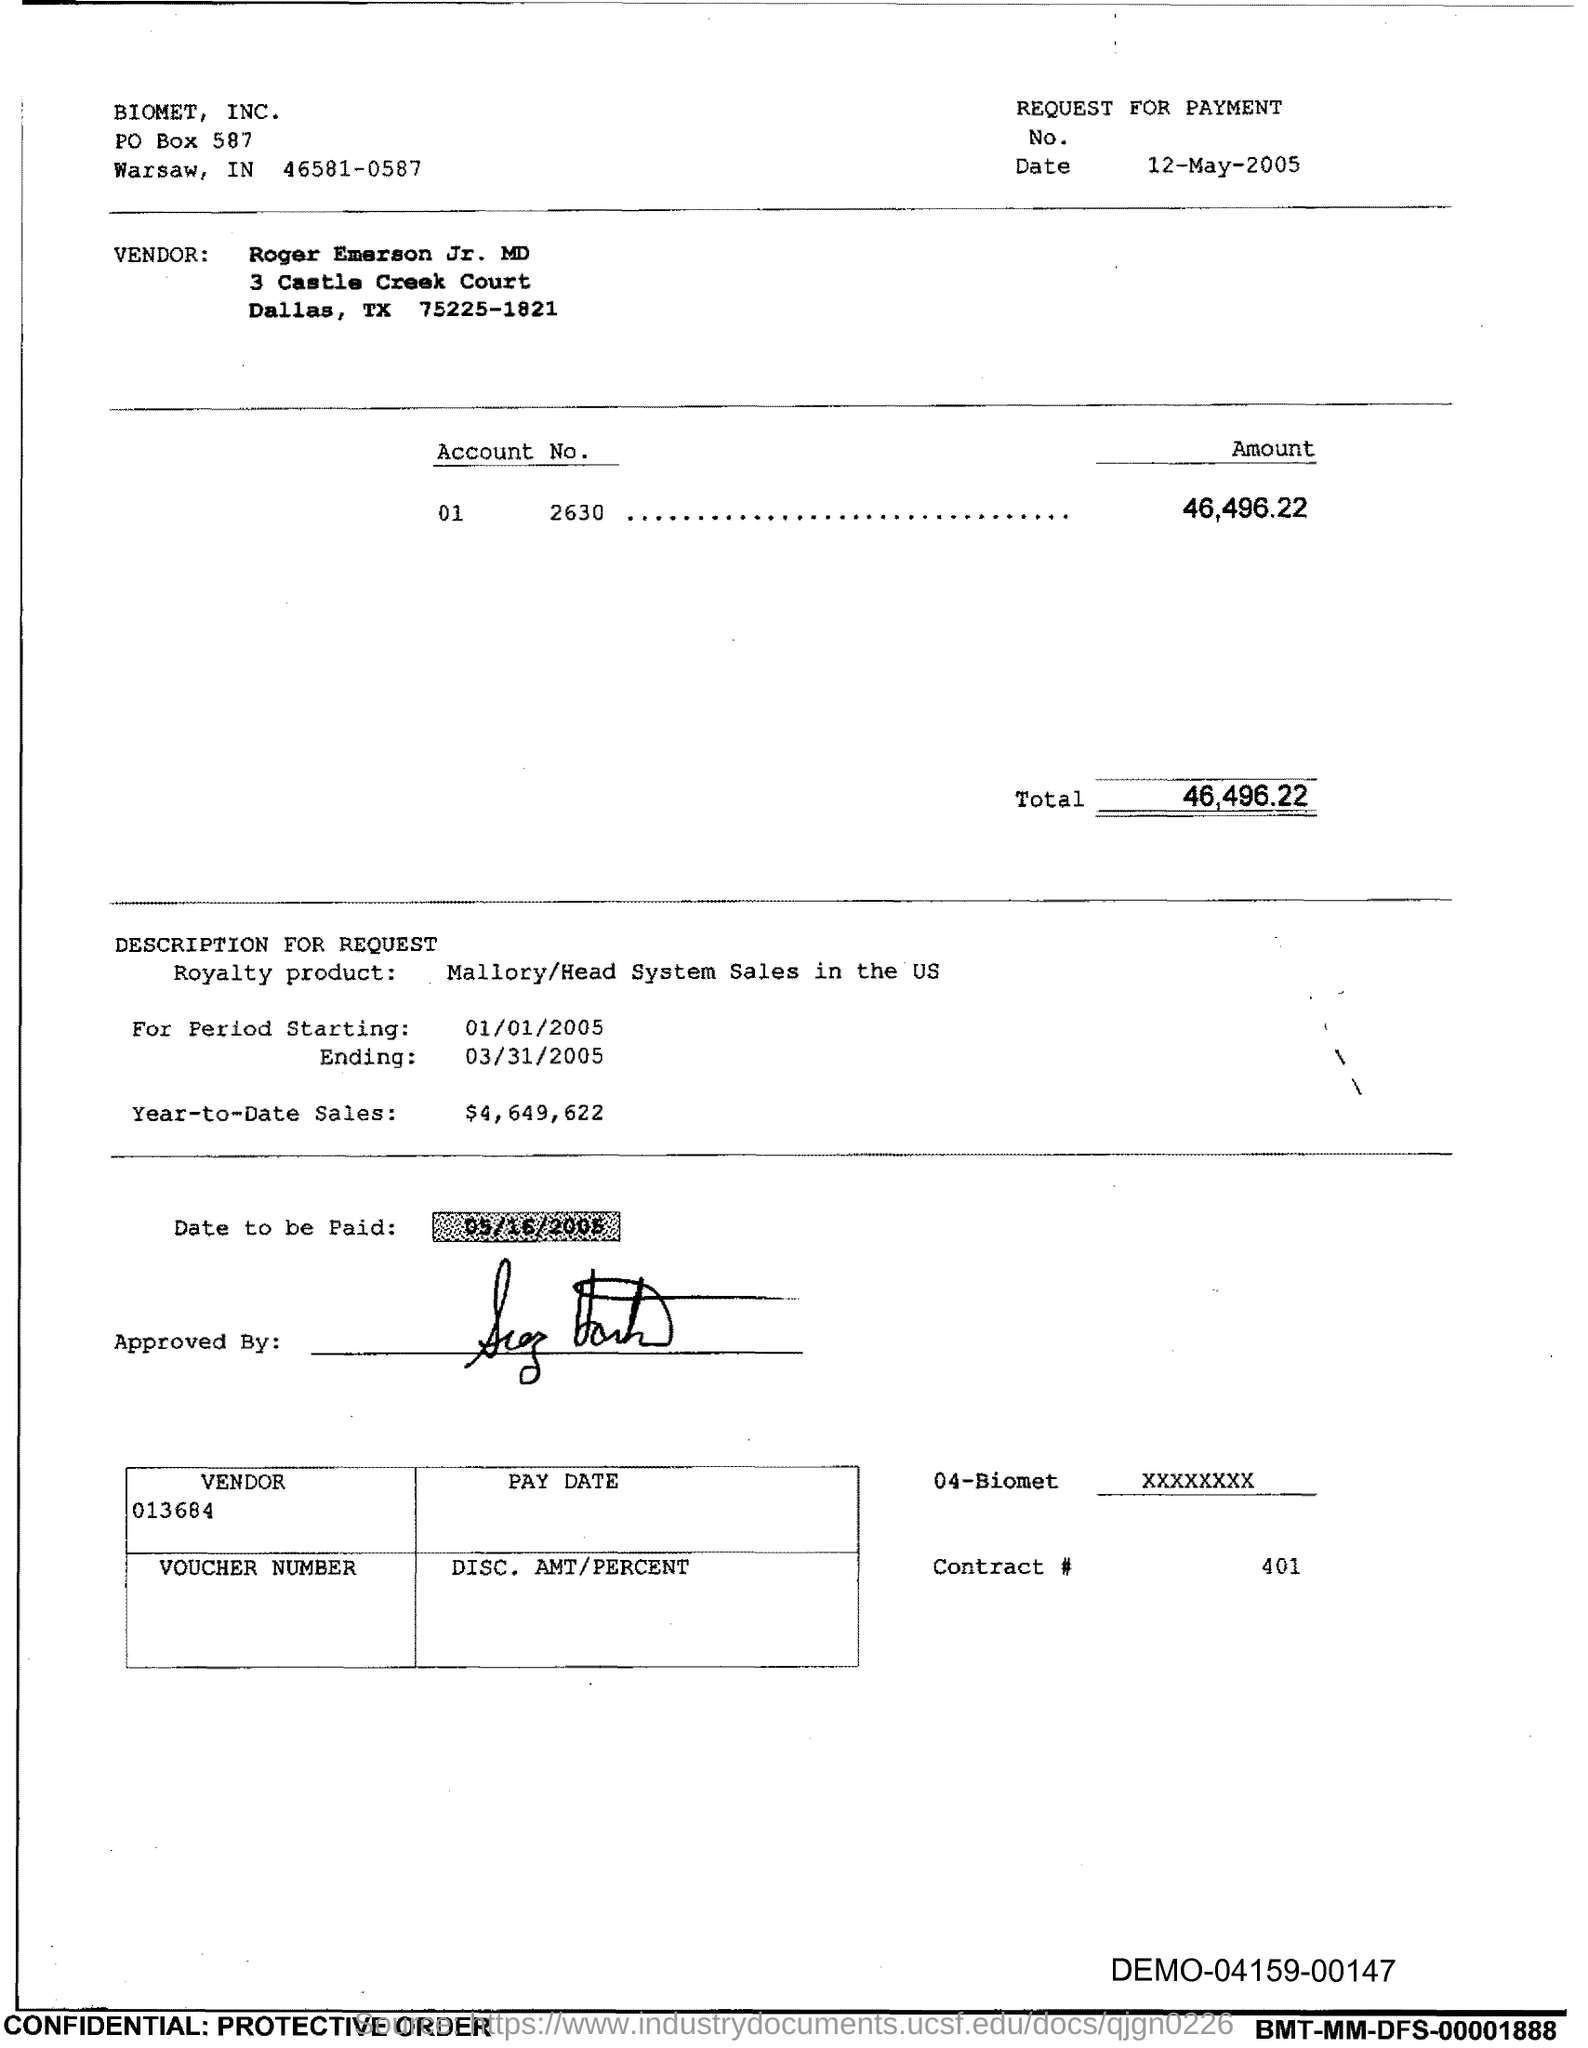Specify some key components in this picture. The date to be paid is May 16th, 2005. The starting period is from January 1, 2005. The total is 46,496.22. The ending period is March 31, 2005. Roger Emerson Jr. is the vendor. 